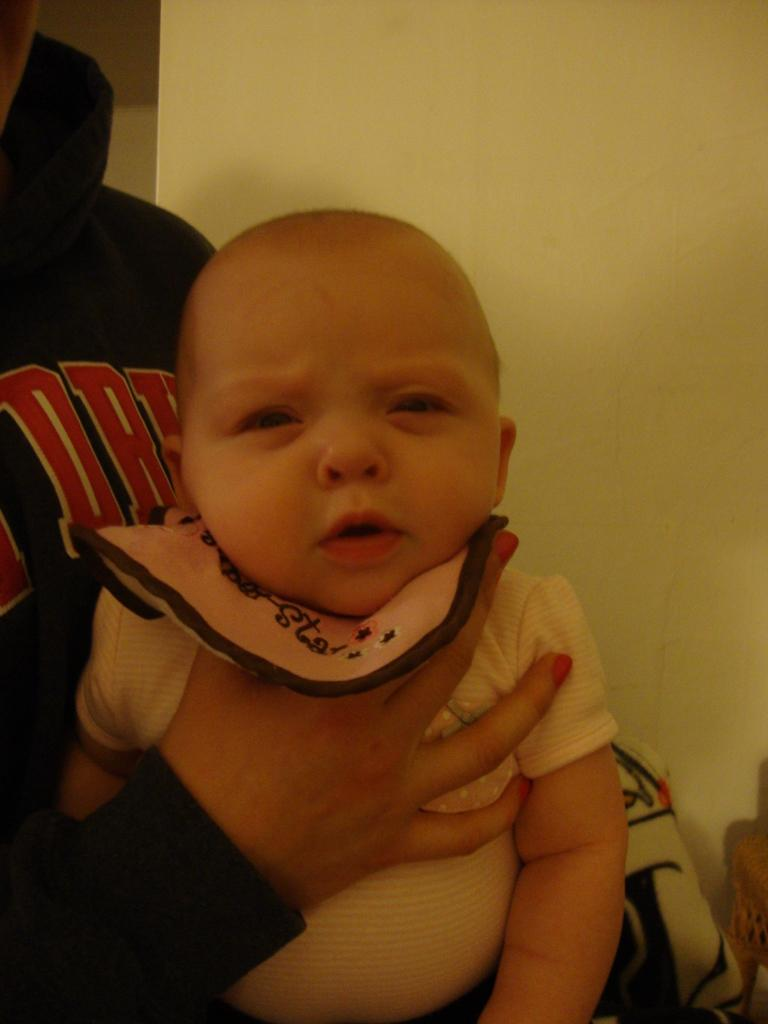What is the person in the image doing? The person is holding a baby in the image. How is the baby being held by the person? The baby is being held on the person's neck. What can be seen in the background of the image? There is a wall visible in the background of the image. What type of plants can be seen growing on the roof in the image? There is no roof or plants visible in the image; it features a person holding a baby with a wall in the background. 